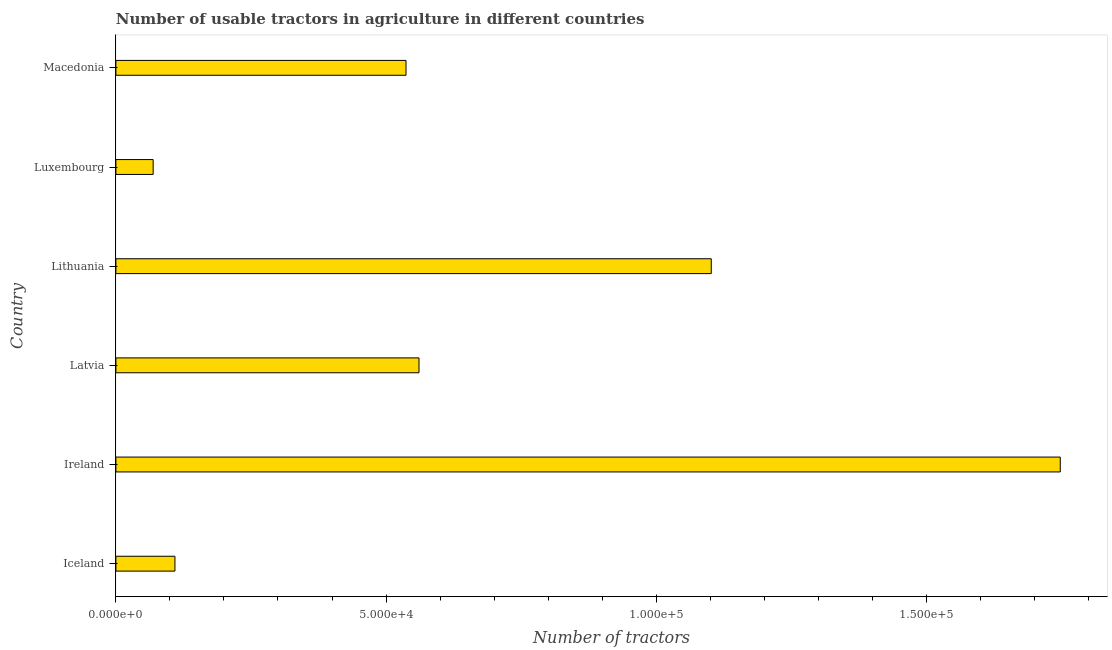Does the graph contain any zero values?
Your response must be concise. No. Does the graph contain grids?
Offer a terse response. No. What is the title of the graph?
Your answer should be compact. Number of usable tractors in agriculture in different countries. What is the label or title of the X-axis?
Give a very brief answer. Number of tractors. What is the number of tractors in Luxembourg?
Keep it short and to the point. 6898. Across all countries, what is the maximum number of tractors?
Offer a terse response. 1.75e+05. Across all countries, what is the minimum number of tractors?
Your response must be concise. 6898. In which country was the number of tractors maximum?
Ensure brevity in your answer.  Ireland. In which country was the number of tractors minimum?
Your answer should be very brief. Luxembourg. What is the sum of the number of tractors?
Offer a terse response. 4.13e+05. What is the difference between the number of tractors in Lithuania and Macedonia?
Your answer should be compact. 5.65e+04. What is the average number of tractors per country?
Your response must be concise. 6.88e+04. What is the median number of tractors?
Keep it short and to the point. 5.49e+04. What is the ratio of the number of tractors in Ireland to that in Luxembourg?
Offer a terse response. 25.34. Is the difference between the number of tractors in Lithuania and Luxembourg greater than the difference between any two countries?
Ensure brevity in your answer.  No. What is the difference between the highest and the second highest number of tractors?
Give a very brief answer. 6.46e+04. Is the sum of the number of tractors in Luxembourg and Macedonia greater than the maximum number of tractors across all countries?
Your response must be concise. No. What is the difference between the highest and the lowest number of tractors?
Your response must be concise. 1.68e+05. In how many countries, is the number of tractors greater than the average number of tractors taken over all countries?
Your answer should be very brief. 2. How many bars are there?
Ensure brevity in your answer.  6. What is the Number of tractors in Iceland?
Make the answer very short. 1.09e+04. What is the Number of tractors in Ireland?
Your answer should be compact. 1.75e+05. What is the Number of tractors in Latvia?
Ensure brevity in your answer.  5.61e+04. What is the Number of tractors of Lithuania?
Make the answer very short. 1.10e+05. What is the Number of tractors in Luxembourg?
Offer a very short reply. 6898. What is the Number of tractors of Macedonia?
Your response must be concise. 5.37e+04. What is the difference between the Number of tractors in Iceland and Ireland?
Make the answer very short. -1.64e+05. What is the difference between the Number of tractors in Iceland and Latvia?
Give a very brief answer. -4.52e+04. What is the difference between the Number of tractors in Iceland and Lithuania?
Your response must be concise. -9.93e+04. What is the difference between the Number of tractors in Iceland and Luxembourg?
Make the answer very short. 4030. What is the difference between the Number of tractors in Iceland and Macedonia?
Give a very brief answer. -4.28e+04. What is the difference between the Number of tractors in Ireland and Latvia?
Ensure brevity in your answer.  1.19e+05. What is the difference between the Number of tractors in Ireland and Lithuania?
Offer a very short reply. 6.46e+04. What is the difference between the Number of tractors in Ireland and Luxembourg?
Your answer should be very brief. 1.68e+05. What is the difference between the Number of tractors in Ireland and Macedonia?
Give a very brief answer. 1.21e+05. What is the difference between the Number of tractors in Latvia and Lithuania?
Provide a succinct answer. -5.41e+04. What is the difference between the Number of tractors in Latvia and Luxembourg?
Ensure brevity in your answer.  4.92e+04. What is the difference between the Number of tractors in Latvia and Macedonia?
Your answer should be compact. 2400. What is the difference between the Number of tractors in Lithuania and Luxembourg?
Your answer should be very brief. 1.03e+05. What is the difference between the Number of tractors in Lithuania and Macedonia?
Your response must be concise. 5.65e+04. What is the difference between the Number of tractors in Luxembourg and Macedonia?
Ensure brevity in your answer.  -4.68e+04. What is the ratio of the Number of tractors in Iceland to that in Ireland?
Offer a very short reply. 0.06. What is the ratio of the Number of tractors in Iceland to that in Latvia?
Keep it short and to the point. 0.2. What is the ratio of the Number of tractors in Iceland to that in Lithuania?
Give a very brief answer. 0.1. What is the ratio of the Number of tractors in Iceland to that in Luxembourg?
Your answer should be compact. 1.58. What is the ratio of the Number of tractors in Iceland to that in Macedonia?
Your answer should be compact. 0.2. What is the ratio of the Number of tractors in Ireland to that in Latvia?
Ensure brevity in your answer.  3.12. What is the ratio of the Number of tractors in Ireland to that in Lithuania?
Your response must be concise. 1.59. What is the ratio of the Number of tractors in Ireland to that in Luxembourg?
Keep it short and to the point. 25.34. What is the ratio of the Number of tractors in Ireland to that in Macedonia?
Provide a short and direct response. 3.25. What is the ratio of the Number of tractors in Latvia to that in Lithuania?
Give a very brief answer. 0.51. What is the ratio of the Number of tractors in Latvia to that in Luxembourg?
Offer a terse response. 8.13. What is the ratio of the Number of tractors in Latvia to that in Macedonia?
Keep it short and to the point. 1.04. What is the ratio of the Number of tractors in Lithuania to that in Luxembourg?
Your response must be concise. 15.98. What is the ratio of the Number of tractors in Lithuania to that in Macedonia?
Your response must be concise. 2.05. What is the ratio of the Number of tractors in Luxembourg to that in Macedonia?
Your answer should be compact. 0.13. 